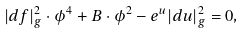Convert formula to latex. <formula><loc_0><loc_0><loc_500><loc_500>| d f | _ { g } ^ { 2 } \cdot \phi ^ { 4 } + B \cdot \phi ^ { 2 } - e ^ { u } | d u | _ { g } ^ { 2 } = 0 ,</formula> 